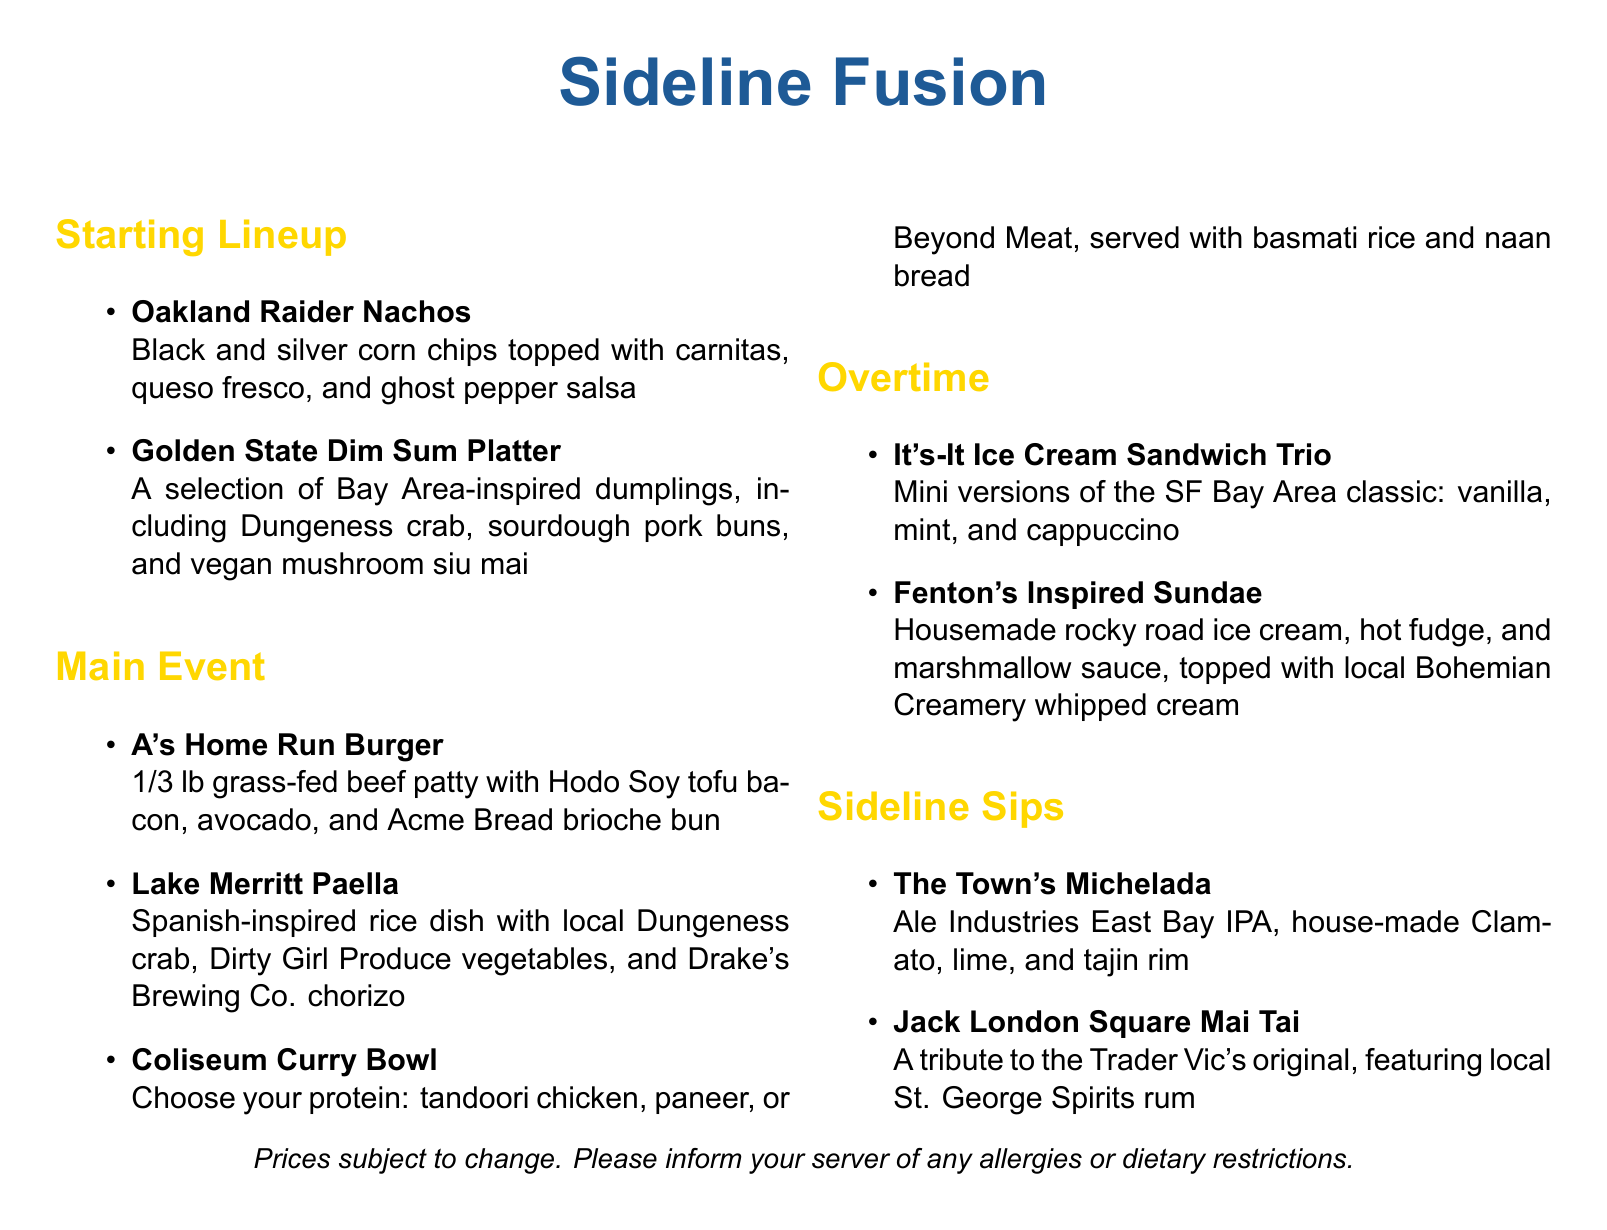What is the name of the burger on the menu? The name of the burger is listed under the Main Event section as "A's Home Run Burger."
Answer: A's Home Run Burger How many types of ice cream sandwiches are offered in the dessert section? The dessert section features a trio of mini ice cream sandwiches, indicating three types are offered.
Answer: Three What protein options are available in the Coliseum Curry Bowl? The document lists the protein options for the Coliseum Curry Bowl: tandoori chicken, paneer, or Beyond Meat.
Answer: Tandoori chicken, paneer, Beyond Meat What type of rum is used in the Jack London Square Mai Tai? The Mai Tai features local St. George Spirits rum as stated in the Sideline Sips section.
Answer: St. George Spirits rum What dish features Dungeness crab? The dish featuring Dungeness crab is mentioned in the Main Event section as "Lake Merritt Paella."
Answer: Lake Merritt Paella What is included in the Golden State Dim Sum Platter? The platter includes Bay Area-inspired dumplings like Dungeness crab, sourdough pork buns, and vegan mushroom siu mai.
Answer: Dungeness crab, sourdough pork buns, vegan mushroom siu mai What is the color of the menu's starting lineup section? The color theme for the Starting Lineup section is represented as sportsgold.
Answer: Sportsgold What beverage has a tajin rim? The beverage with a tajin rim is referred to as "The Town's Michelada" in the Sideline Sips section.
Answer: The Town's Michelada 